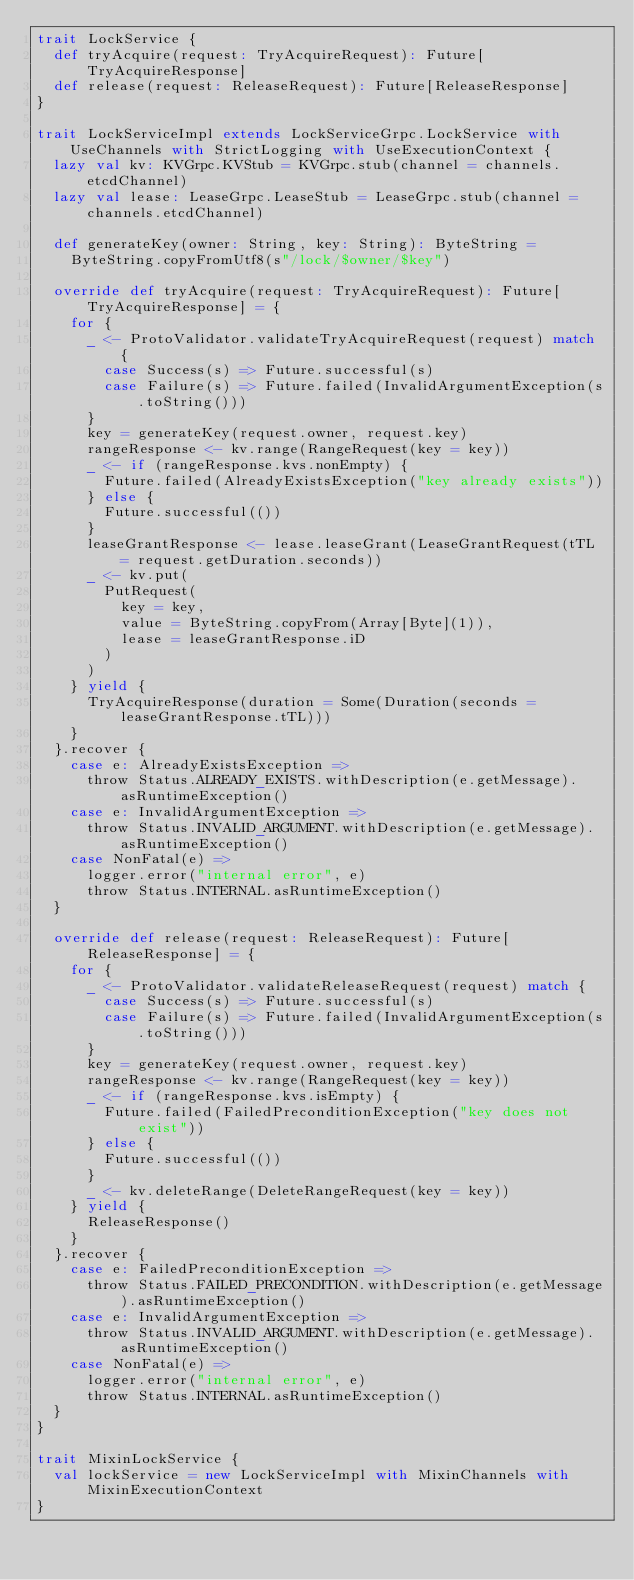<code> <loc_0><loc_0><loc_500><loc_500><_Scala_>trait LockService {
  def tryAcquire(request: TryAcquireRequest): Future[TryAcquireResponse]
  def release(request: ReleaseRequest): Future[ReleaseResponse]
}

trait LockServiceImpl extends LockServiceGrpc.LockService with UseChannels with StrictLogging with UseExecutionContext {
  lazy val kv: KVGrpc.KVStub = KVGrpc.stub(channel = channels.etcdChannel)
  lazy val lease: LeaseGrpc.LeaseStub = LeaseGrpc.stub(channel = channels.etcdChannel)

  def generateKey(owner: String, key: String): ByteString =
    ByteString.copyFromUtf8(s"/lock/$owner/$key")

  override def tryAcquire(request: TryAcquireRequest): Future[TryAcquireResponse] = {
    for {
      _ <- ProtoValidator.validateTryAcquireRequest(request) match {
        case Success(s) => Future.successful(s)
        case Failure(s) => Future.failed(InvalidArgumentException(s.toString()))
      }
      key = generateKey(request.owner, request.key)
      rangeResponse <- kv.range(RangeRequest(key = key))
      _ <- if (rangeResponse.kvs.nonEmpty) {
        Future.failed(AlreadyExistsException("key already exists"))
      } else {
        Future.successful(())
      }
      leaseGrantResponse <- lease.leaseGrant(LeaseGrantRequest(tTL = request.getDuration.seconds))
      _ <- kv.put(
        PutRequest(
          key = key,
          value = ByteString.copyFrom(Array[Byte](1)),
          lease = leaseGrantResponse.iD
        )
      )
    } yield {
      TryAcquireResponse(duration = Some(Duration(seconds = leaseGrantResponse.tTL)))
    }
  }.recover {
    case e: AlreadyExistsException =>
      throw Status.ALREADY_EXISTS.withDescription(e.getMessage).asRuntimeException()
    case e: InvalidArgumentException =>
      throw Status.INVALID_ARGUMENT.withDescription(e.getMessage).asRuntimeException()
    case NonFatal(e) =>
      logger.error("internal error", e)
      throw Status.INTERNAL.asRuntimeException()
  }

  override def release(request: ReleaseRequest): Future[ReleaseResponse] = {
    for {
      _ <- ProtoValidator.validateReleaseRequest(request) match {
        case Success(s) => Future.successful(s)
        case Failure(s) => Future.failed(InvalidArgumentException(s.toString()))
      }
      key = generateKey(request.owner, request.key)
      rangeResponse <- kv.range(RangeRequest(key = key))
      _ <- if (rangeResponse.kvs.isEmpty) {
        Future.failed(FailedPreconditionException("key does not exist"))
      } else {
        Future.successful(())
      }
      _ <- kv.deleteRange(DeleteRangeRequest(key = key))
    } yield {
      ReleaseResponse()
    }
  }.recover {
    case e: FailedPreconditionException =>
      throw Status.FAILED_PRECONDITION.withDescription(e.getMessage).asRuntimeException()
    case e: InvalidArgumentException =>
      throw Status.INVALID_ARGUMENT.withDescription(e.getMessage).asRuntimeException()
    case NonFatal(e) =>
      logger.error("internal error", e)
      throw Status.INTERNAL.asRuntimeException()
  }
}

trait MixinLockService {
  val lockService = new LockServiceImpl with MixinChannels with MixinExecutionContext
}
</code> 